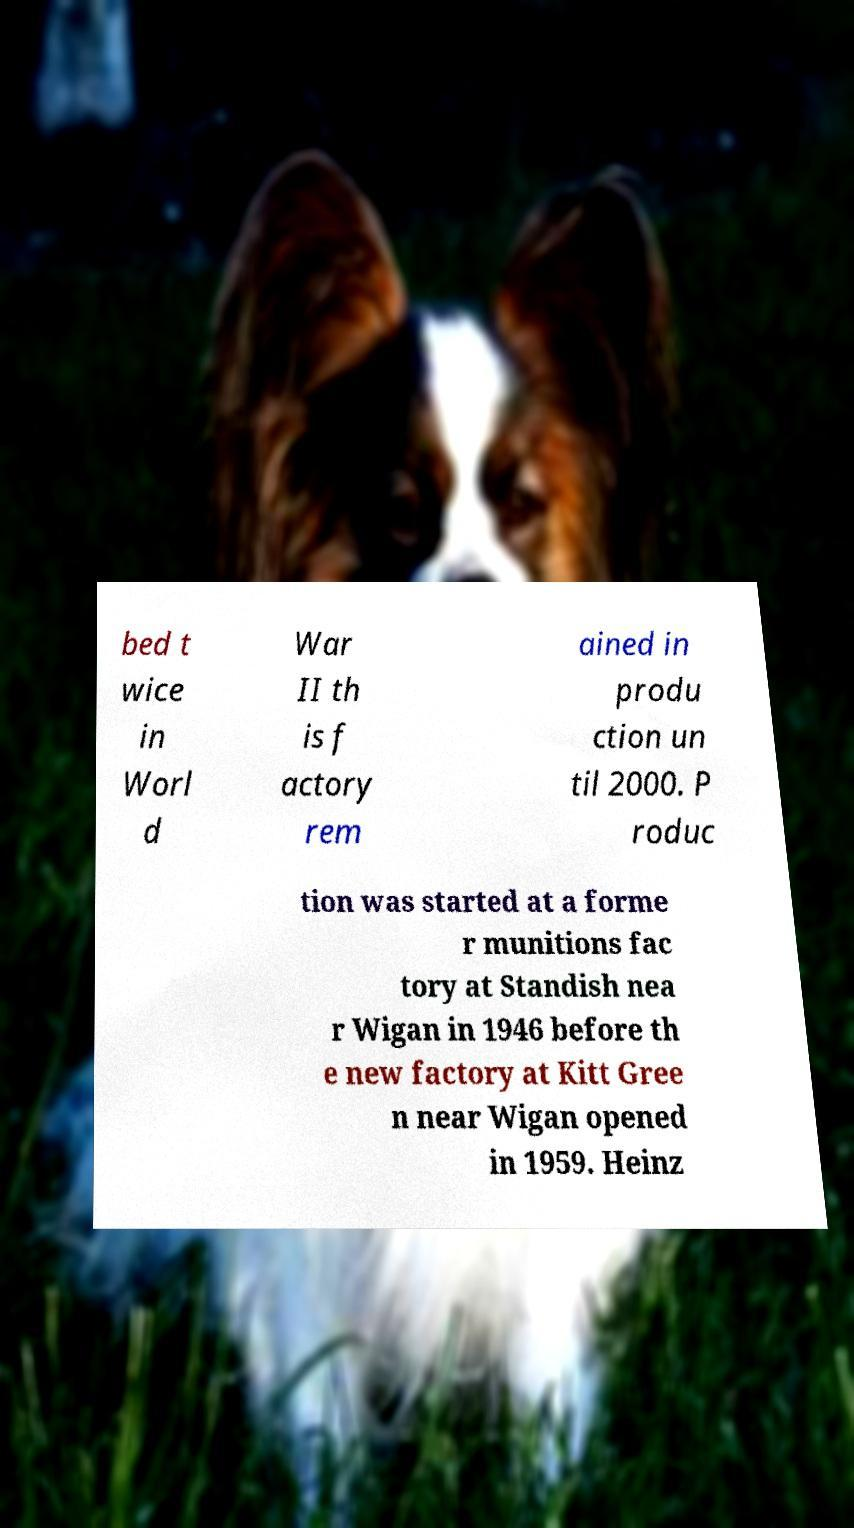Could you assist in decoding the text presented in this image and type it out clearly? bed t wice in Worl d War II th is f actory rem ained in produ ction un til 2000. P roduc tion was started at a forme r munitions fac tory at Standish nea r Wigan in 1946 before th e new factory at Kitt Gree n near Wigan opened in 1959. Heinz 